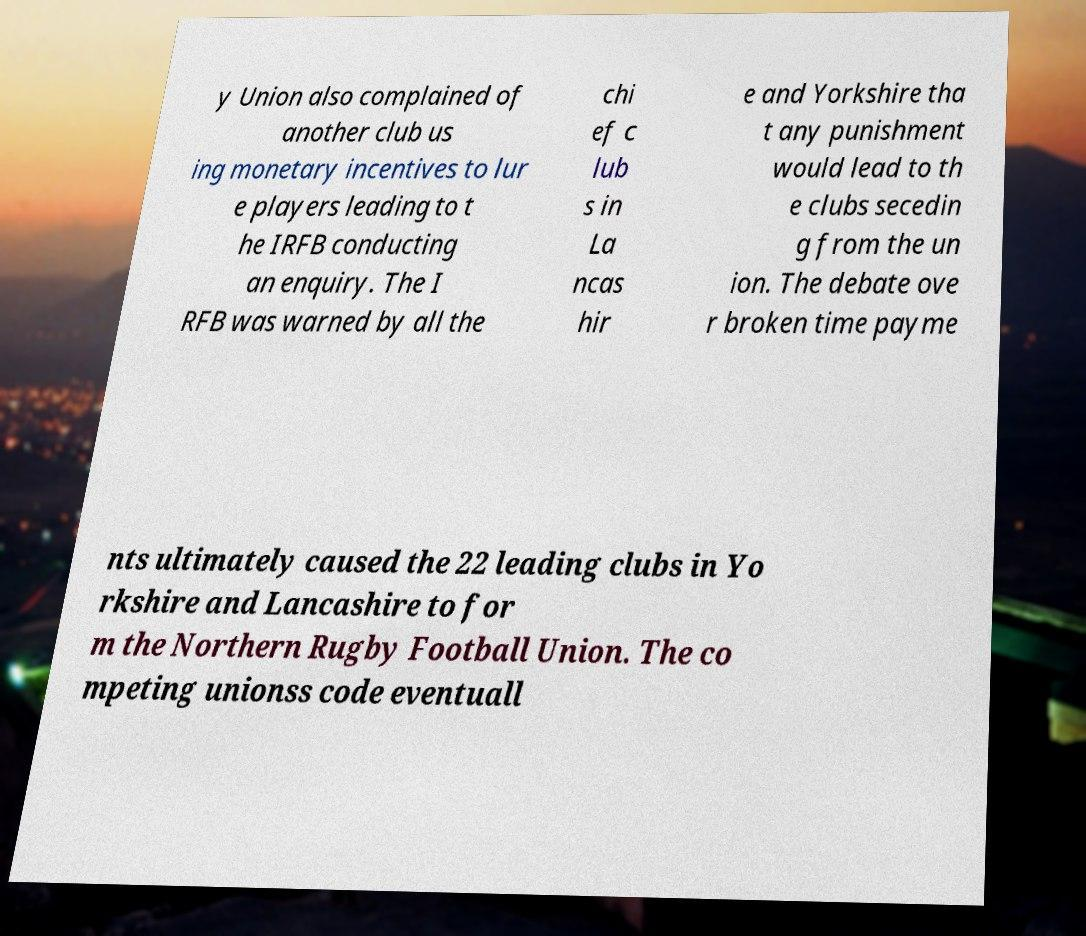I need the written content from this picture converted into text. Can you do that? y Union also complained of another club us ing monetary incentives to lur e players leading to t he IRFB conducting an enquiry. The I RFB was warned by all the chi ef c lub s in La ncas hir e and Yorkshire tha t any punishment would lead to th e clubs secedin g from the un ion. The debate ove r broken time payme nts ultimately caused the 22 leading clubs in Yo rkshire and Lancashire to for m the Northern Rugby Football Union. The co mpeting unionss code eventuall 